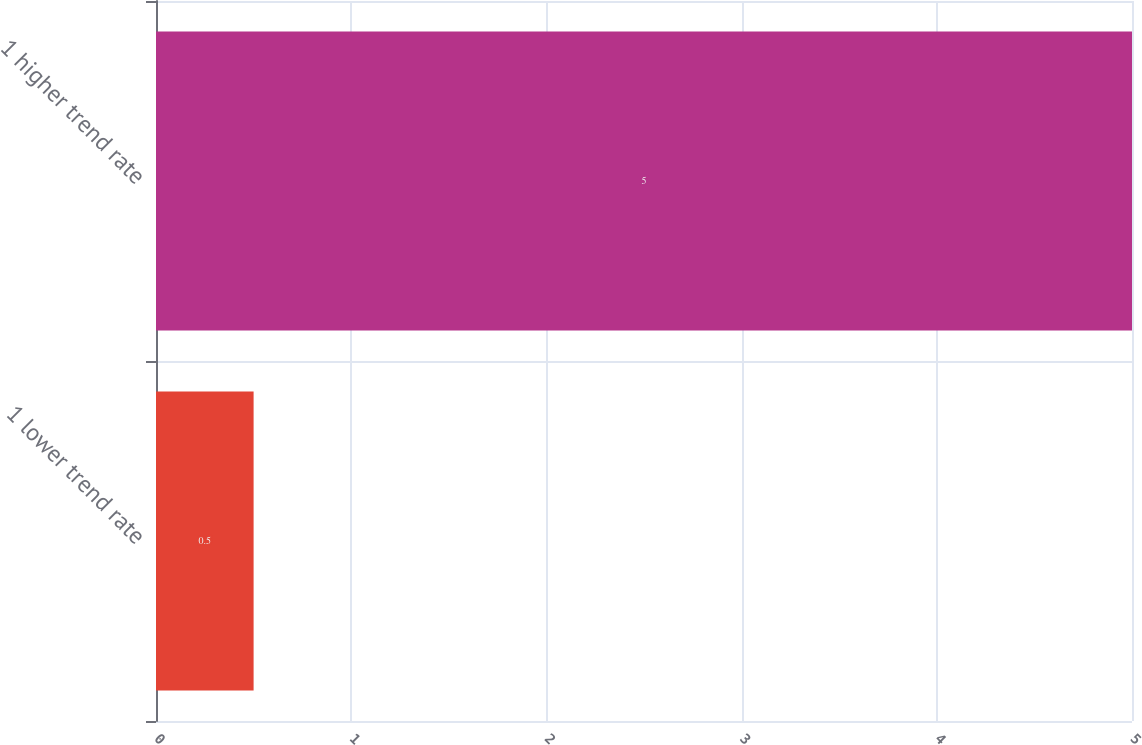Convert chart to OTSL. <chart><loc_0><loc_0><loc_500><loc_500><bar_chart><fcel>1 lower trend rate<fcel>1 higher trend rate<nl><fcel>0.5<fcel>5<nl></chart> 